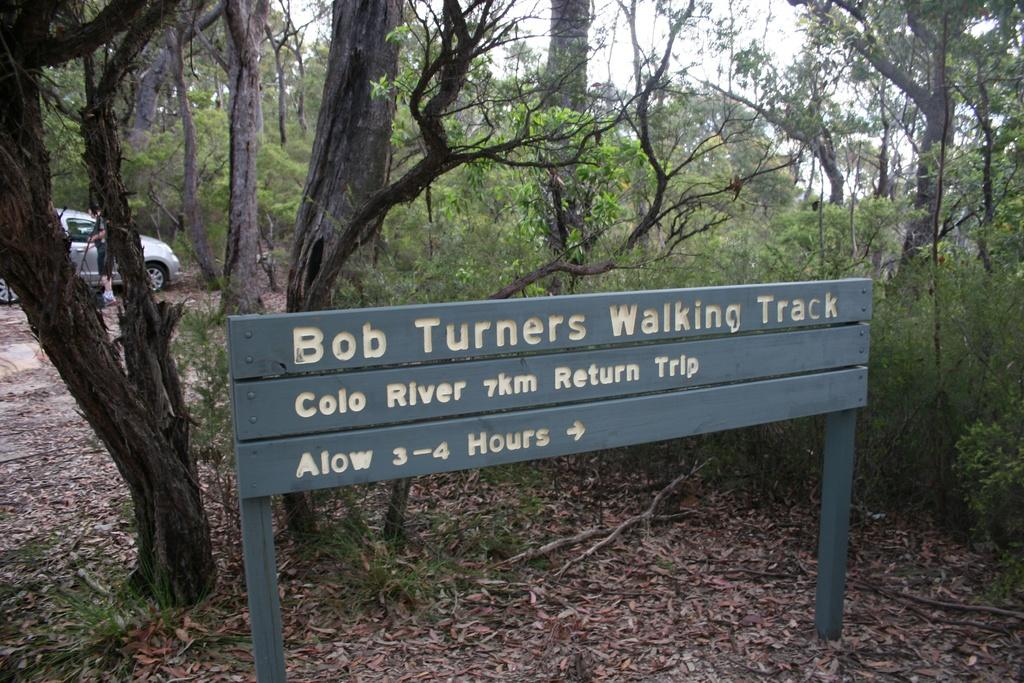What can be found in the image that provides information? There is an information board in the image. What is on the ground in the image? Shredded leaves are present on the ground. What type of natural elements are in the image? There are trees in the image. What mode of transportation can be seen in the image? A motor vehicle is visible in the image. Who is present in the image? There is a person standing in the image. What body of water is in the image? There is a pond in the image. What part of the environment is visible in the image? The sky is visible in the image. What type of shirt is the father wearing in the image? There is no father or shirt present in the image. How many feet are visible in the image? There is no mention of feet in the image; it only shows a person standing and a motor vehicle. 